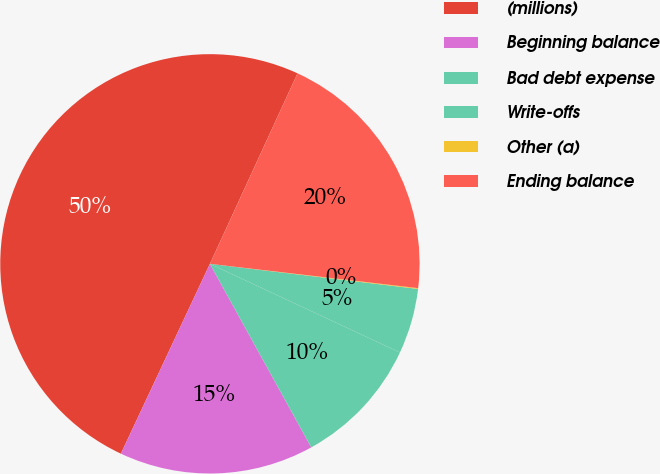Convert chart to OTSL. <chart><loc_0><loc_0><loc_500><loc_500><pie_chart><fcel>(millions)<fcel>Beginning balance<fcel>Bad debt expense<fcel>Write-offs<fcel>Other (a)<fcel>Ending balance<nl><fcel>49.88%<fcel>15.01%<fcel>10.02%<fcel>5.04%<fcel>0.06%<fcel>19.99%<nl></chart> 